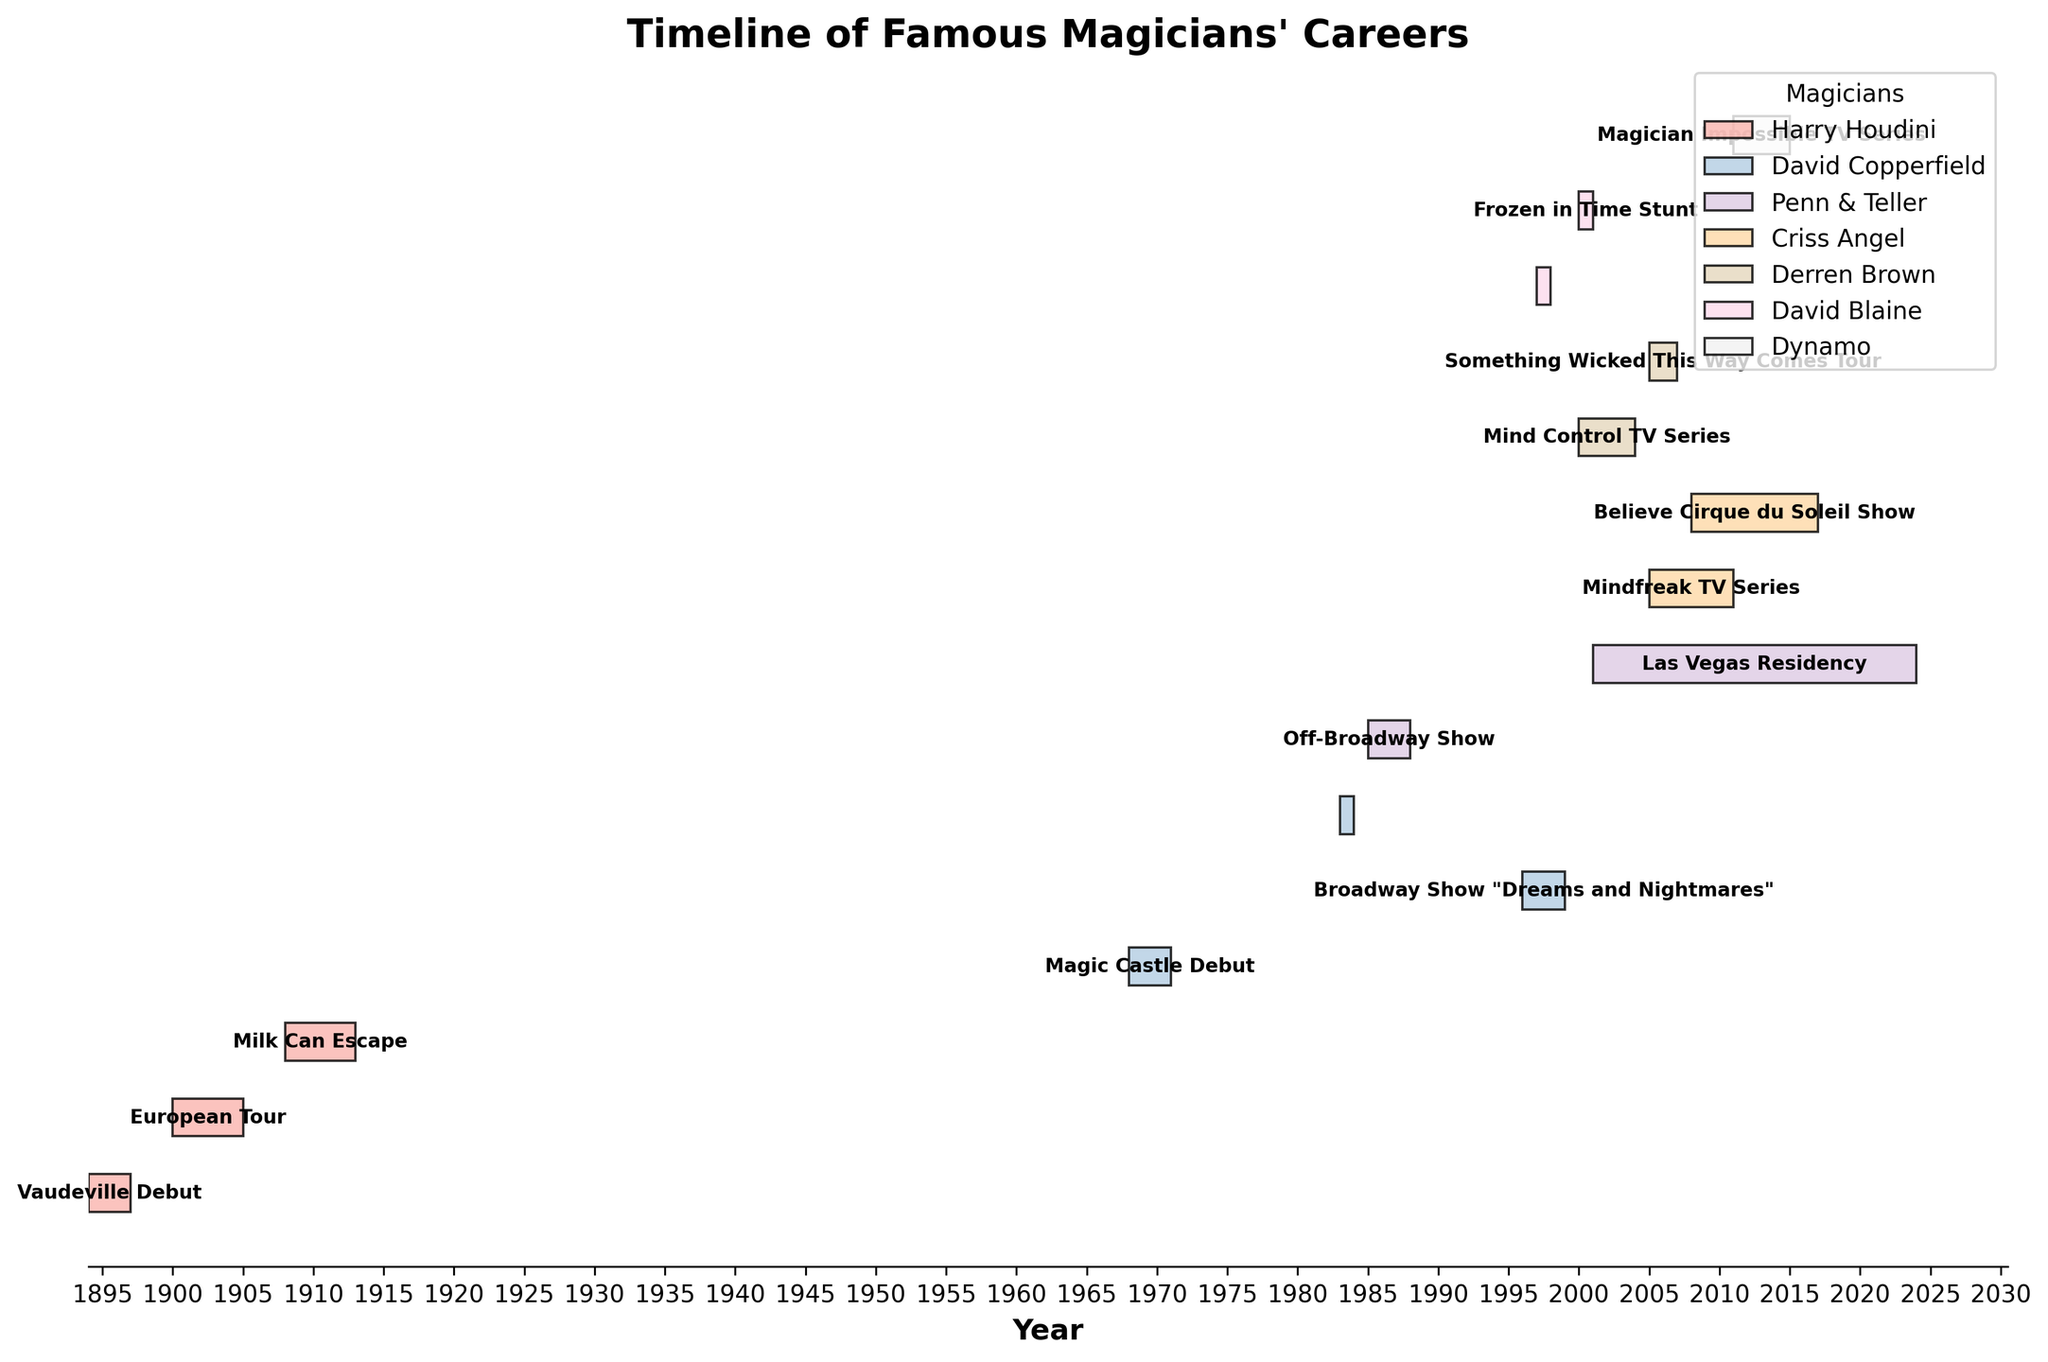what's the title of the figure? The title is usually at the top of the figure. In this case, the title reads "Timeline of Famous Magicians' Careers."
Answer: Timeline of Famous Magicians' Careers Which magician had the longest single event? Look at the lengths of the bars and identify the longest one. Penn & Teller's "Las Vegas Residency" spans from 2001 to 2023, which is 23 years.
Answer: Penn & Teller Which event did Harry Houdini perform first? Look at Harry Houdini's entries in the figure. His earliest event is "Vaudeville Debut," which started in 1894.
Answer: Vaudeville Debut When did Criss Angel's "Mindfreak TV Series" event start and end? Check the timeline for Criss Angel's "Mindfreak TV Series" entry. It started in 2005 and ended in 2010.
Answer: 2005 - 2010 Compare the duration of David Blaine's "Street Magic TV Special" with his "Frozen in Time Stunt." Which lasted longer? Both events are highlighted on the timeline for David Blaine. The "Street Magic TV Special" in 1997 and the "Frozen in Time Stunt" in 2000. Both events occurred within a single year.
Answer: Neither, both lasted 1 year How many major performances or breakthroughs did David Copperfield have? Count the number of bars associated with David Copperfield in the figure. He has three events: "Magic Castle Debut," "Broadway Show 'Dreams and Nightmares'," and "Statue of Liberty Disappearance."
Answer: 3 What event did Dynamo perform after his "Magician Impossible TV Series"? Look at the timeline for Dynamo. "Magician Impossible TV Series" is his only event shown, so there is no subsequent event listed for him.
Answer: None Which magician has an event spanning from 2000 to 2003? Check the timeline entries for events within this period. Derren Brown's "Mind Control TV Series" fits this description.
Answer: Derren Brown Did Penn & Teller's "Off-Broadway Show" or "Las Vegas Residency" last longer? Compare the duration bars for Penn & Teller's events. Their "Off-Broadway Show" ran from 1985 to 1987 (3 years), while "Las Vegas Residency" ran from 2001 to 2023 (23 years).
Answer: Las Vegas Residency What is the latest ending year for any event in the figure? Check the end years of all the events. The latest end year is 2023, which corresponds to Penn & Teller's "Las Vegas Residency."
Answer: 2023 